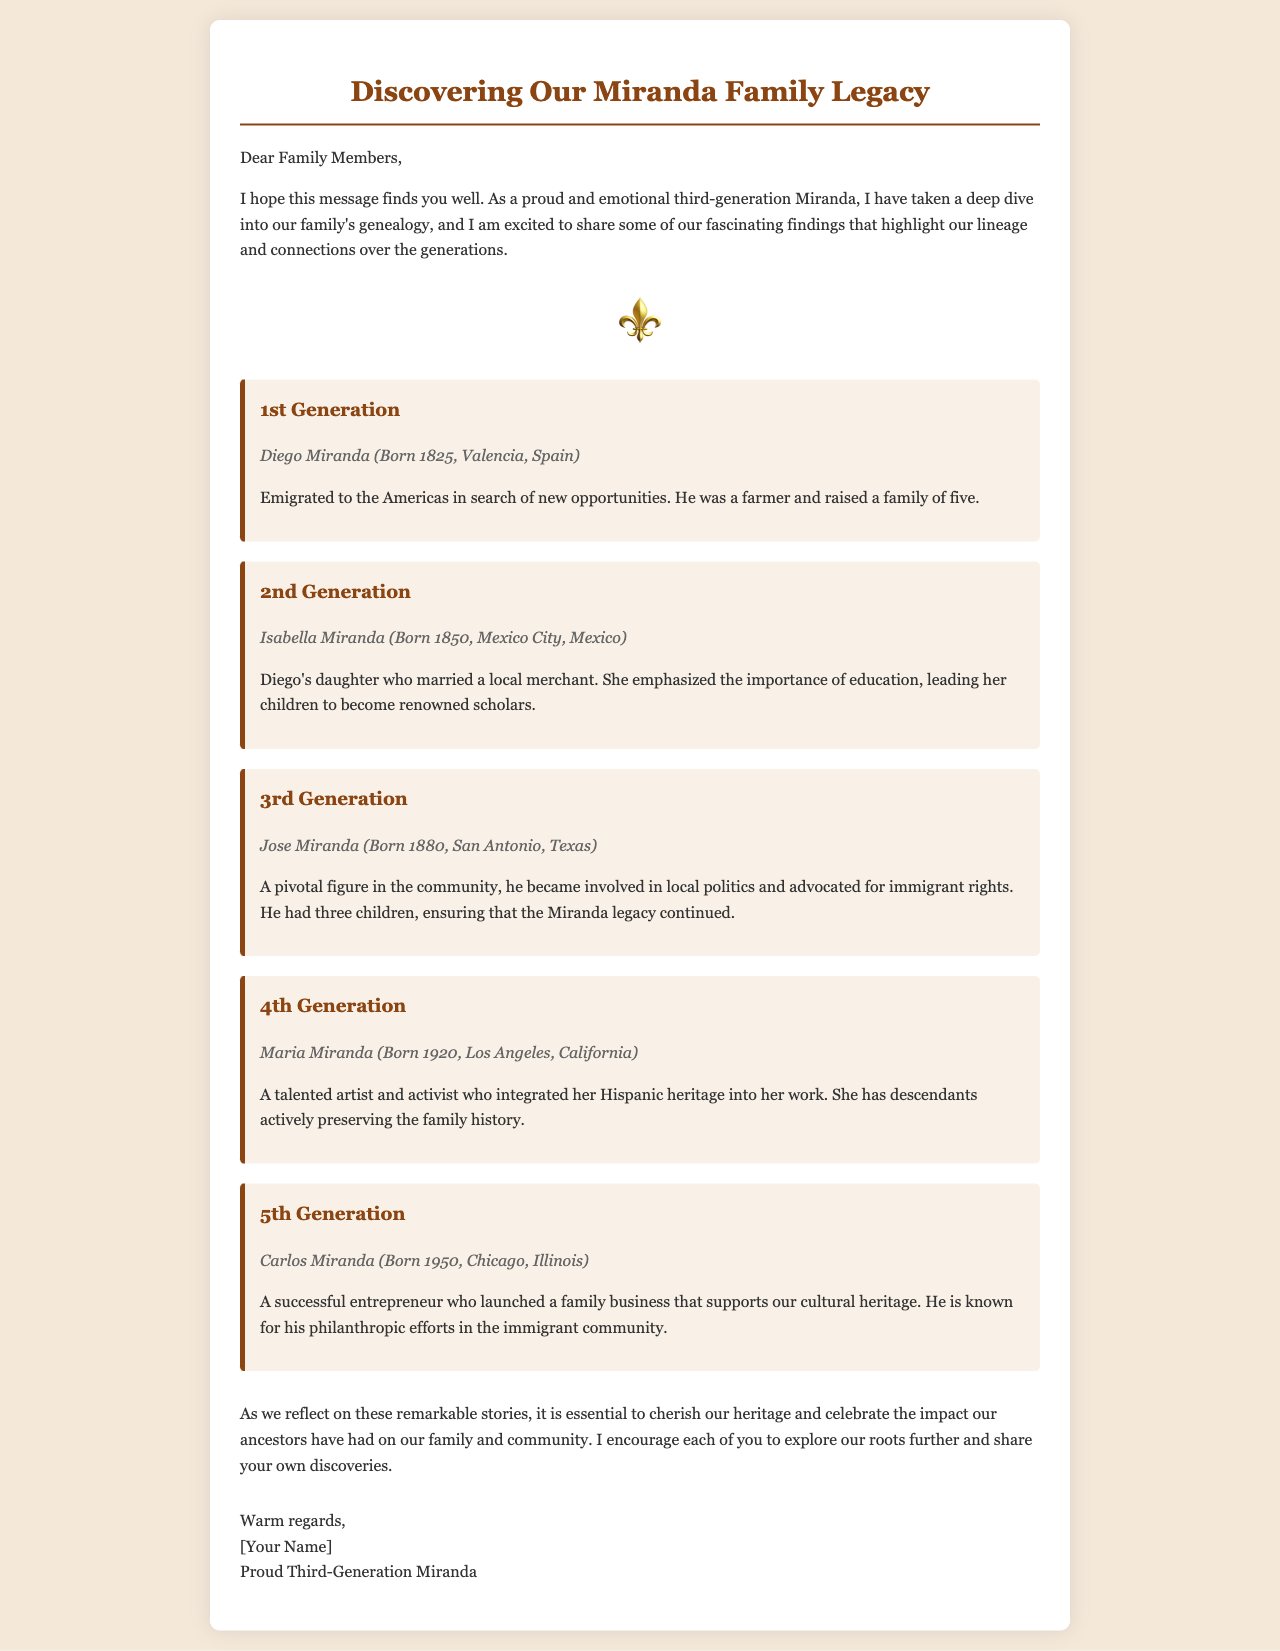What is the birthplace of Diego Miranda? Diego Miranda was born in Valencia, Spain, as stated in the document.
Answer: Valencia, Spain What year was Isabella Miranda born? The document specifies that Isabella Miranda was born in 1850.
Answer: 1850 What was Jose Miranda's role in the community? The document mentions that Jose Miranda became involved in local politics and advocated for immigrant rights.
Answer: Local politics How many children did Maria Miranda have? The document asserts that Maria Miranda has descendants currently preserving the family history, but does not specify a number for her children.
Answer: Not specified What is Carlos Miranda known for? According to the document, Carlos Miranda is known for his philanthropic efforts in the immigrant community.
Answer: Philanthropic efforts Which generation did Diego Miranda belong to? The document categorizes Diego Miranda as part of the 1st Generation.
Answer: 1st Generation What notable contribution did Isabella Miranda make? Isabella Miranda emphasized the importance of education for her children, leading them to become renowned scholars.
Answer: Education What is the primary theme of this email? The email focuses on the genealogy and lineage of the Miranda family over generations.
Answer: Family genealogy Who is the author of the email? The document concludes with a sign-off indicating the author is a proud third-generation Miranda.
Answer: [Your Name] 